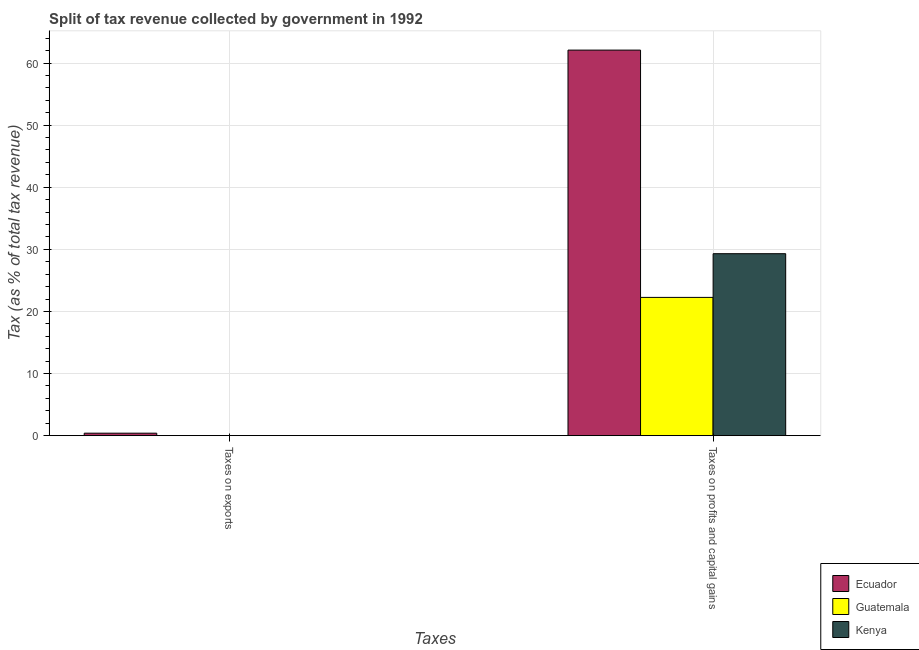How many different coloured bars are there?
Provide a succinct answer. 3. What is the label of the 2nd group of bars from the left?
Offer a very short reply. Taxes on profits and capital gains. What is the percentage of revenue obtained from taxes on profits and capital gains in Ecuador?
Provide a succinct answer. 62.08. Across all countries, what is the maximum percentage of revenue obtained from taxes on profits and capital gains?
Offer a terse response. 62.08. Across all countries, what is the minimum percentage of revenue obtained from taxes on exports?
Offer a very short reply. 0. In which country was the percentage of revenue obtained from taxes on exports maximum?
Keep it short and to the point. Ecuador. In which country was the percentage of revenue obtained from taxes on profits and capital gains minimum?
Make the answer very short. Guatemala. What is the total percentage of revenue obtained from taxes on exports in the graph?
Offer a very short reply. 0.42. What is the difference between the percentage of revenue obtained from taxes on exports in Ecuador and that in Guatemala?
Your answer should be very brief. 0.38. What is the difference between the percentage of revenue obtained from taxes on exports in Ecuador and the percentage of revenue obtained from taxes on profits and capital gains in Kenya?
Keep it short and to the point. -28.9. What is the average percentage of revenue obtained from taxes on profits and capital gains per country?
Your answer should be very brief. 37.88. What is the difference between the percentage of revenue obtained from taxes on profits and capital gains and percentage of revenue obtained from taxes on exports in Guatemala?
Keep it short and to the point. 22.24. What is the ratio of the percentage of revenue obtained from taxes on exports in Guatemala to that in Kenya?
Provide a succinct answer. 4.77. Is the percentage of revenue obtained from taxes on profits and capital gains in Guatemala less than that in Ecuador?
Provide a succinct answer. Yes. In how many countries, is the percentage of revenue obtained from taxes on exports greater than the average percentage of revenue obtained from taxes on exports taken over all countries?
Your response must be concise. 1. What does the 1st bar from the left in Taxes on exports represents?
Your response must be concise. Ecuador. What does the 3rd bar from the right in Taxes on exports represents?
Your response must be concise. Ecuador. How many bars are there?
Offer a very short reply. 6. How many countries are there in the graph?
Your response must be concise. 3. Where does the legend appear in the graph?
Offer a terse response. Bottom right. How many legend labels are there?
Offer a terse response. 3. What is the title of the graph?
Provide a short and direct response. Split of tax revenue collected by government in 1992. What is the label or title of the X-axis?
Your response must be concise. Taxes. What is the label or title of the Y-axis?
Make the answer very short. Tax (as % of total tax revenue). What is the Tax (as % of total tax revenue) in Ecuador in Taxes on exports?
Ensure brevity in your answer.  0.4. What is the Tax (as % of total tax revenue) of Guatemala in Taxes on exports?
Provide a succinct answer. 0.02. What is the Tax (as % of total tax revenue) of Kenya in Taxes on exports?
Keep it short and to the point. 0. What is the Tax (as % of total tax revenue) of Ecuador in Taxes on profits and capital gains?
Offer a very short reply. 62.08. What is the Tax (as % of total tax revenue) of Guatemala in Taxes on profits and capital gains?
Give a very brief answer. 22.26. What is the Tax (as % of total tax revenue) in Kenya in Taxes on profits and capital gains?
Give a very brief answer. 29.3. Across all Taxes, what is the maximum Tax (as % of total tax revenue) of Ecuador?
Offer a very short reply. 62.08. Across all Taxes, what is the maximum Tax (as % of total tax revenue) in Guatemala?
Your response must be concise. 22.26. Across all Taxes, what is the maximum Tax (as % of total tax revenue) in Kenya?
Offer a terse response. 29.3. Across all Taxes, what is the minimum Tax (as % of total tax revenue) of Ecuador?
Provide a succinct answer. 0.4. Across all Taxes, what is the minimum Tax (as % of total tax revenue) of Guatemala?
Ensure brevity in your answer.  0.02. Across all Taxes, what is the minimum Tax (as % of total tax revenue) of Kenya?
Keep it short and to the point. 0. What is the total Tax (as % of total tax revenue) of Ecuador in the graph?
Provide a short and direct response. 62.48. What is the total Tax (as % of total tax revenue) in Guatemala in the graph?
Provide a succinct answer. 22.28. What is the total Tax (as % of total tax revenue) of Kenya in the graph?
Offer a very short reply. 29.3. What is the difference between the Tax (as % of total tax revenue) in Ecuador in Taxes on exports and that in Taxes on profits and capital gains?
Provide a short and direct response. -61.68. What is the difference between the Tax (as % of total tax revenue) in Guatemala in Taxes on exports and that in Taxes on profits and capital gains?
Offer a terse response. -22.24. What is the difference between the Tax (as % of total tax revenue) in Kenya in Taxes on exports and that in Taxes on profits and capital gains?
Offer a very short reply. -29.29. What is the difference between the Tax (as % of total tax revenue) in Ecuador in Taxes on exports and the Tax (as % of total tax revenue) in Guatemala in Taxes on profits and capital gains?
Offer a very short reply. -21.86. What is the difference between the Tax (as % of total tax revenue) of Ecuador in Taxes on exports and the Tax (as % of total tax revenue) of Kenya in Taxes on profits and capital gains?
Your answer should be very brief. -28.9. What is the difference between the Tax (as % of total tax revenue) of Guatemala in Taxes on exports and the Tax (as % of total tax revenue) of Kenya in Taxes on profits and capital gains?
Offer a very short reply. -29.28. What is the average Tax (as % of total tax revenue) in Ecuador per Taxes?
Provide a short and direct response. 31.24. What is the average Tax (as % of total tax revenue) in Guatemala per Taxes?
Offer a terse response. 11.14. What is the average Tax (as % of total tax revenue) in Kenya per Taxes?
Provide a succinct answer. 14.65. What is the difference between the Tax (as % of total tax revenue) in Ecuador and Tax (as % of total tax revenue) in Guatemala in Taxes on exports?
Provide a succinct answer. 0.38. What is the difference between the Tax (as % of total tax revenue) in Ecuador and Tax (as % of total tax revenue) in Kenya in Taxes on exports?
Provide a succinct answer. 0.39. What is the difference between the Tax (as % of total tax revenue) in Guatemala and Tax (as % of total tax revenue) in Kenya in Taxes on exports?
Provide a succinct answer. 0.02. What is the difference between the Tax (as % of total tax revenue) in Ecuador and Tax (as % of total tax revenue) in Guatemala in Taxes on profits and capital gains?
Offer a very short reply. 39.82. What is the difference between the Tax (as % of total tax revenue) in Ecuador and Tax (as % of total tax revenue) in Kenya in Taxes on profits and capital gains?
Your answer should be very brief. 32.78. What is the difference between the Tax (as % of total tax revenue) in Guatemala and Tax (as % of total tax revenue) in Kenya in Taxes on profits and capital gains?
Ensure brevity in your answer.  -7.04. What is the ratio of the Tax (as % of total tax revenue) of Ecuador in Taxes on exports to that in Taxes on profits and capital gains?
Your answer should be very brief. 0.01. What is the ratio of the Tax (as % of total tax revenue) of Guatemala in Taxes on exports to that in Taxes on profits and capital gains?
Keep it short and to the point. 0. What is the difference between the highest and the second highest Tax (as % of total tax revenue) of Ecuador?
Make the answer very short. 61.68. What is the difference between the highest and the second highest Tax (as % of total tax revenue) of Guatemala?
Provide a short and direct response. 22.24. What is the difference between the highest and the second highest Tax (as % of total tax revenue) in Kenya?
Give a very brief answer. 29.29. What is the difference between the highest and the lowest Tax (as % of total tax revenue) in Ecuador?
Your answer should be compact. 61.68. What is the difference between the highest and the lowest Tax (as % of total tax revenue) in Guatemala?
Your response must be concise. 22.24. What is the difference between the highest and the lowest Tax (as % of total tax revenue) of Kenya?
Make the answer very short. 29.29. 